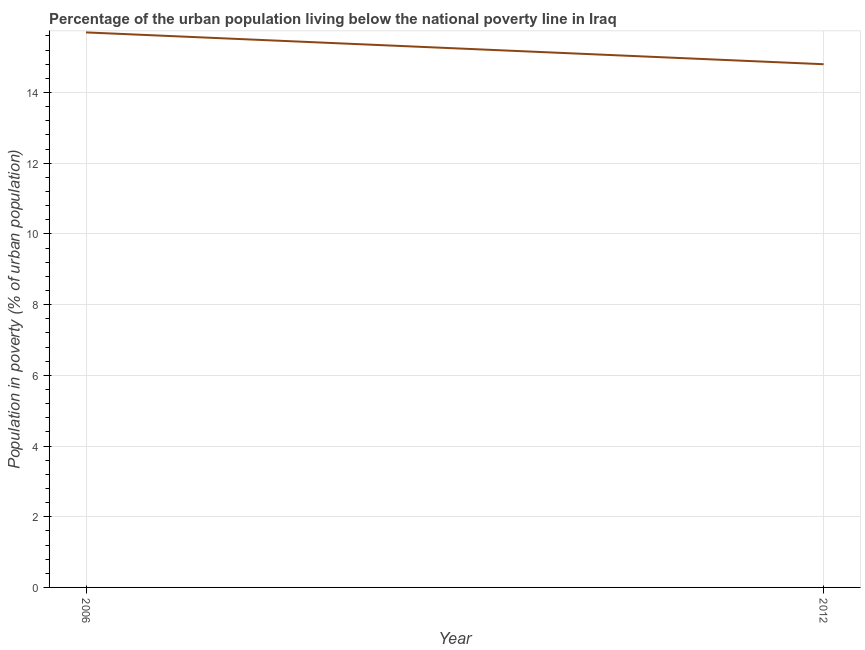Across all years, what is the maximum percentage of urban population living below poverty line?
Provide a short and direct response. 15.7. In which year was the percentage of urban population living below poverty line maximum?
Give a very brief answer. 2006. What is the sum of the percentage of urban population living below poverty line?
Offer a terse response. 30.5. What is the difference between the percentage of urban population living below poverty line in 2006 and 2012?
Ensure brevity in your answer.  0.9. What is the average percentage of urban population living below poverty line per year?
Ensure brevity in your answer.  15.25. What is the median percentage of urban population living below poverty line?
Your response must be concise. 15.25. In how many years, is the percentage of urban population living below poverty line greater than 14 %?
Offer a very short reply. 2. Do a majority of the years between 2006 and 2012 (inclusive) have percentage of urban population living below poverty line greater than 7.2 %?
Provide a short and direct response. Yes. What is the ratio of the percentage of urban population living below poverty line in 2006 to that in 2012?
Your answer should be very brief. 1.06. Is the percentage of urban population living below poverty line in 2006 less than that in 2012?
Ensure brevity in your answer.  No. What is the title of the graph?
Ensure brevity in your answer.  Percentage of the urban population living below the national poverty line in Iraq. What is the label or title of the X-axis?
Make the answer very short. Year. What is the label or title of the Y-axis?
Provide a succinct answer. Population in poverty (% of urban population). What is the Population in poverty (% of urban population) of 2012?
Provide a short and direct response. 14.8. What is the difference between the Population in poverty (% of urban population) in 2006 and 2012?
Make the answer very short. 0.9. What is the ratio of the Population in poverty (% of urban population) in 2006 to that in 2012?
Your answer should be compact. 1.06. 